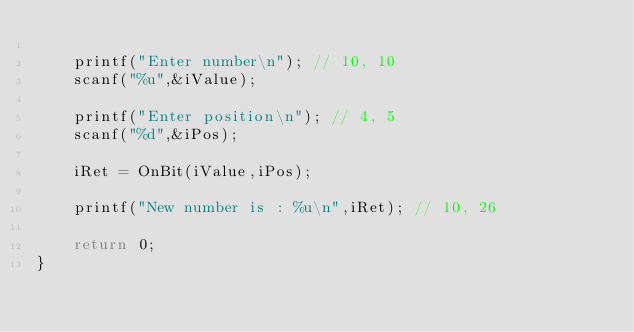<code> <loc_0><loc_0><loc_500><loc_500><_C_>
    printf("Enter number\n"); // 10, 10
    scanf("%u",&iValue);
    
    printf("Enter position\n"); // 4, 5
    scanf("%d",&iPos);
    
    iRet = OnBit(iValue,iPos);
    
    printf("New number is : %u\n",iRet); // 10, 26
    
    return 0;
}
</code> 